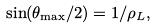<formula> <loc_0><loc_0><loc_500><loc_500>\sin ( \theta _ { \max } / 2 ) = 1 / \rho _ { L } ,</formula> 